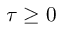Convert formula to latex. <formula><loc_0><loc_0><loc_500><loc_500>\tau \geq 0</formula> 